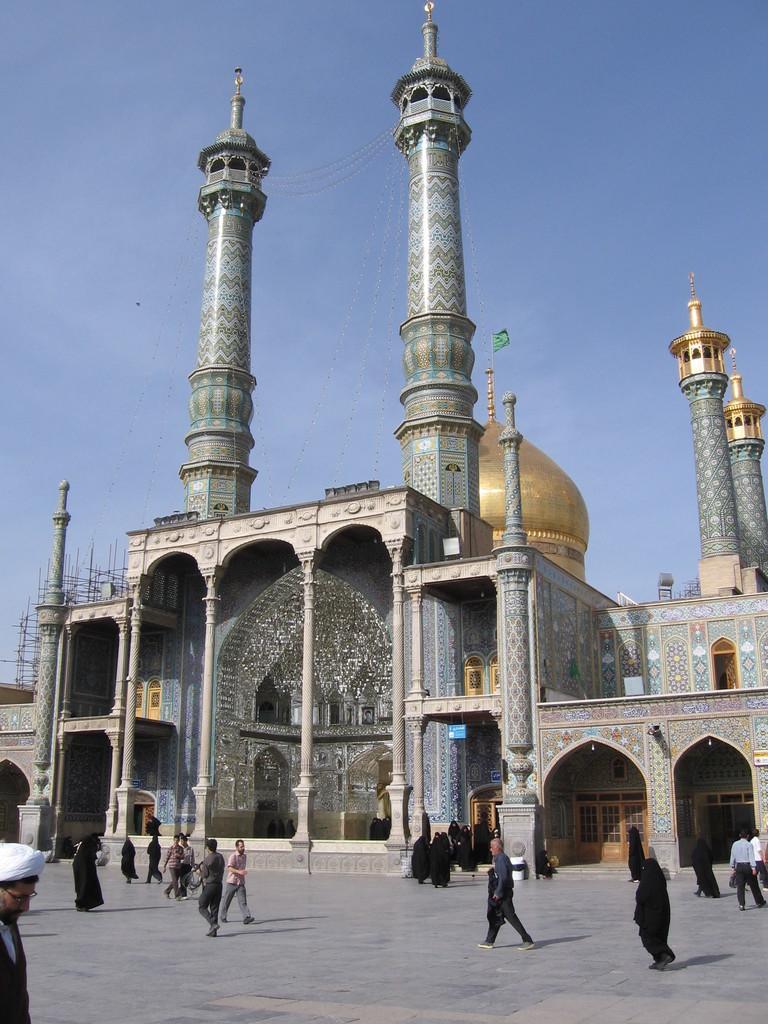Could you give a brief overview of what you see in this image? There is a building in the picture which is a sacred place for muslims. Many of the muslim women are moving into the building and some of the people are walking in front of it. There is an open space in front of the building and we can observe two towers on the building and a dome behind the building. A flag is also located on the top of the dome. Beside the dome there are two towers. And in the background we can observe sky. 